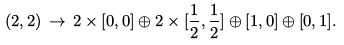<formula> <loc_0><loc_0><loc_500><loc_500>( 2 , 2 ) \, \rightarrow \, 2 \times [ 0 , 0 ] \oplus 2 \times [ \frac { 1 } { 2 } , \frac { 1 } { 2 } ] \oplus [ 1 , 0 ] \oplus [ 0 , 1 ] .</formula> 